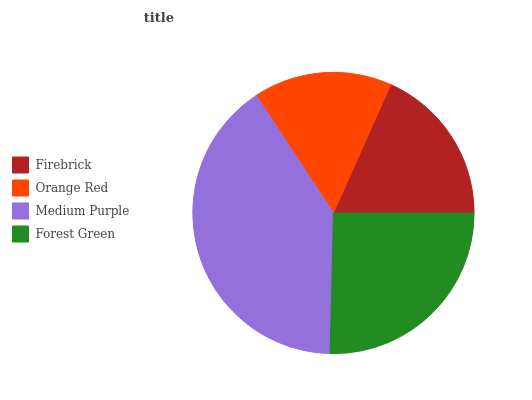Is Orange Red the minimum?
Answer yes or no. Yes. Is Medium Purple the maximum?
Answer yes or no. Yes. Is Medium Purple the minimum?
Answer yes or no. No. Is Orange Red the maximum?
Answer yes or no. No. Is Medium Purple greater than Orange Red?
Answer yes or no. Yes. Is Orange Red less than Medium Purple?
Answer yes or no. Yes. Is Orange Red greater than Medium Purple?
Answer yes or no. No. Is Medium Purple less than Orange Red?
Answer yes or no. No. Is Forest Green the high median?
Answer yes or no. Yes. Is Firebrick the low median?
Answer yes or no. Yes. Is Orange Red the high median?
Answer yes or no. No. Is Medium Purple the low median?
Answer yes or no. No. 